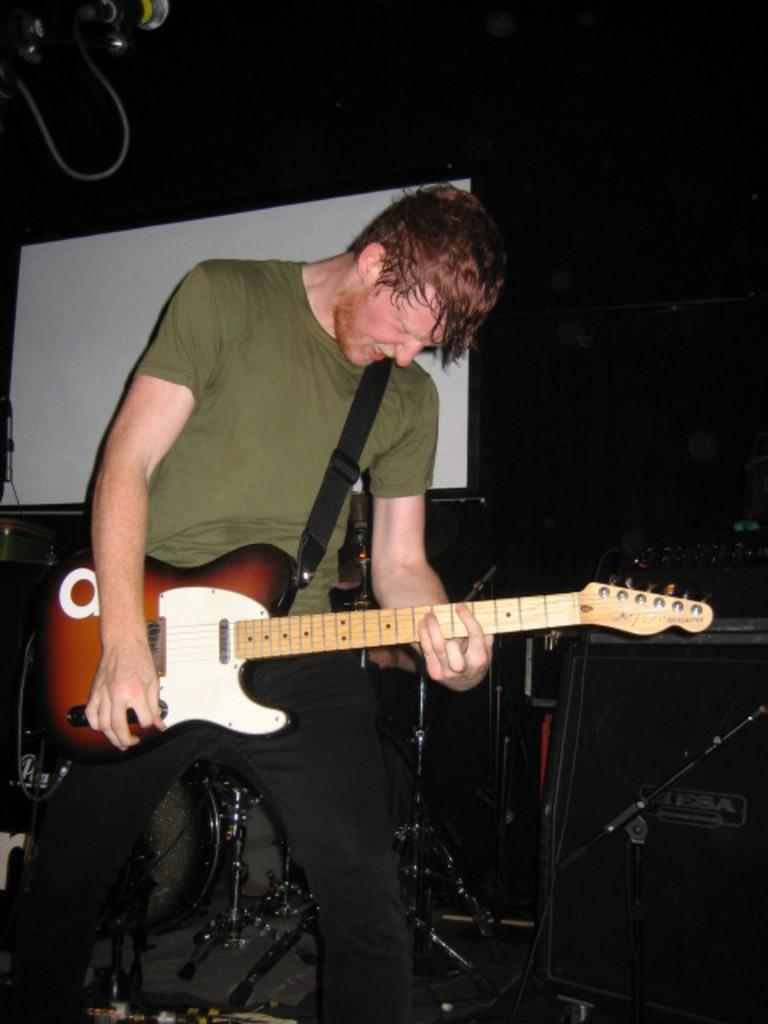What is the main subject of the image? There is a man in the image. What is the man wearing? The man is wearing a red shirt. What object is the man holding? The man is holding a guitar. What can be seen behind the man in the image? There is a white banner behind the man. What type of knee injury is the man experiencing in the image? There is no indication of a knee injury in the image; the man is standing and holding a guitar. What sound can be heard coming from the guitar in the image? The image is static, so no sound can be heard from the guitar. 